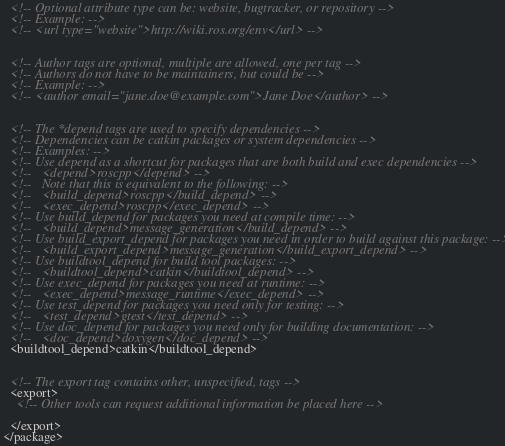<code> <loc_0><loc_0><loc_500><loc_500><_XML_>  <!-- Optional attribute type can be: website, bugtracker, or repository -->
  <!-- Example: -->
  <!-- <url type="website">http://wiki.ros.org/env</url> -->


  <!-- Author tags are optional, multiple are allowed, one per tag -->
  <!-- Authors do not have to be maintainers, but could be -->
  <!-- Example: -->
  <!-- <author email="jane.doe@example.com">Jane Doe</author> -->


  <!-- The *depend tags are used to specify dependencies -->
  <!-- Dependencies can be catkin packages or system dependencies -->
  <!-- Examples: -->
  <!-- Use depend as a shortcut for packages that are both build and exec dependencies -->
  <!--   <depend>roscpp</depend> -->
  <!--   Note that this is equivalent to the following: -->
  <!--   <build_depend>roscpp</build_depend> -->
  <!--   <exec_depend>roscpp</exec_depend> -->
  <!-- Use build_depend for packages you need at compile time: -->
  <!--   <build_depend>message_generation</build_depend> -->
  <!-- Use build_export_depend for packages you need in order to build against this package: -->
  <!--   <build_export_depend>message_generation</build_export_depend> -->
  <!-- Use buildtool_depend for build tool packages: -->
  <!--   <buildtool_depend>catkin</buildtool_depend> -->
  <!-- Use exec_depend for packages you need at runtime: -->
  <!--   <exec_depend>message_runtime</exec_depend> -->
  <!-- Use test_depend for packages you need only for testing: -->
  <!--   <test_depend>gtest</test_depend> -->
  <!-- Use doc_depend for packages you need only for building documentation: -->
  <!--   <doc_depend>doxygen</doc_depend> -->
  <buildtool_depend>catkin</buildtool_depend>


  <!-- The export tag contains other, unspecified, tags -->
  <export>
    <!-- Other tools can request additional information be placed here -->

  </export>
</package>
</code> 